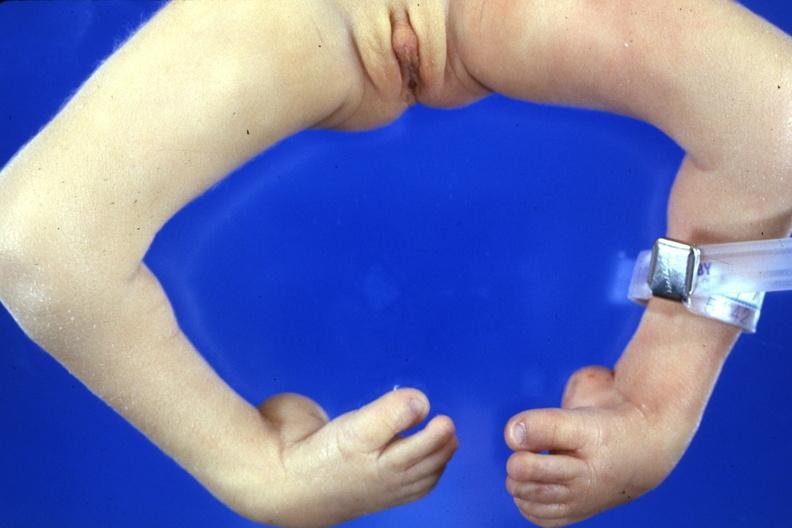re extremities present?
Answer the question using a single word or phrase. Yes 